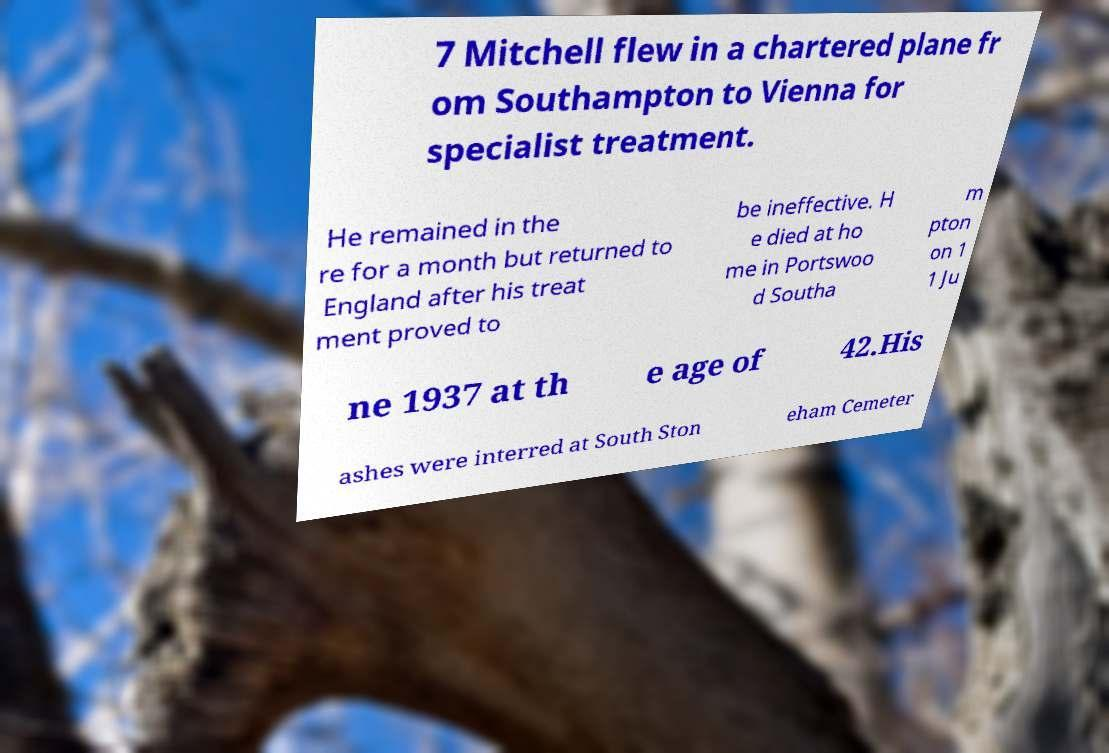For documentation purposes, I need the text within this image transcribed. Could you provide that? 7 Mitchell flew in a chartered plane fr om Southampton to Vienna for specialist treatment. He remained in the re for a month but returned to England after his treat ment proved to be ineffective. H e died at ho me in Portswoo d Southa m pton on 1 1 Ju ne 1937 at th e age of 42.His ashes were interred at South Ston eham Cemeter 